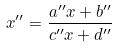<formula> <loc_0><loc_0><loc_500><loc_500>x ^ { \prime \prime } = \frac { a ^ { \prime \prime } x + b ^ { \prime \prime } } { c ^ { \prime \prime } x + d ^ { \prime \prime } }</formula> 